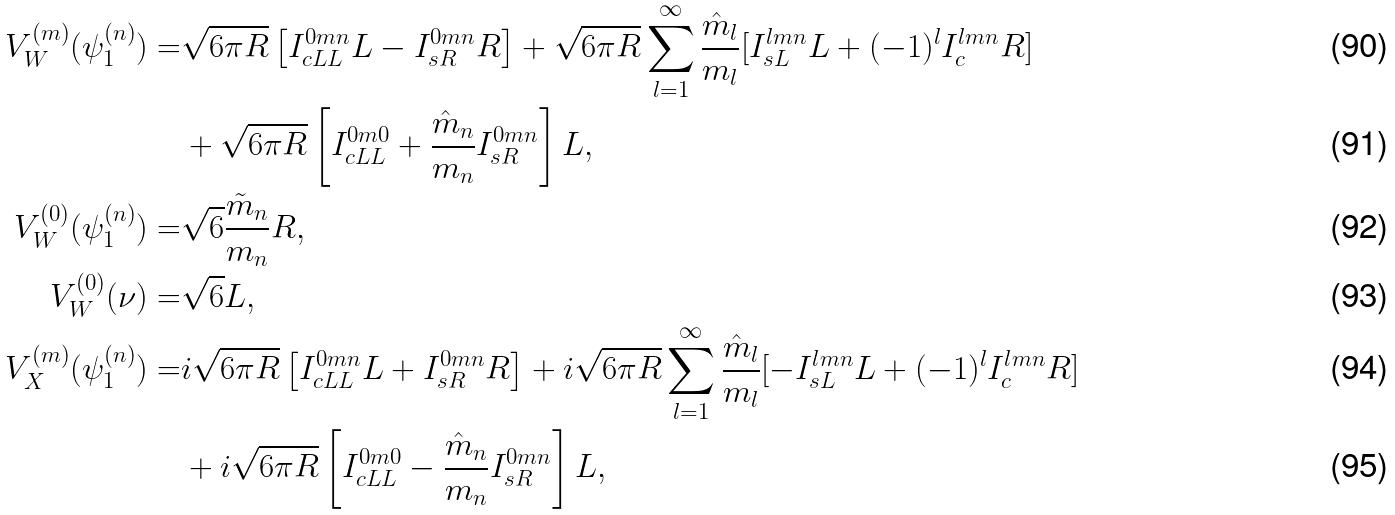<formula> <loc_0><loc_0><loc_500><loc_500>V _ { W } ^ { ( m ) } ( \psi _ { 1 } ^ { ( n ) } ) = & \sqrt { 6 \pi R } \left [ I _ { c L L } ^ { 0 m n } L - I _ { s R } ^ { 0 m n } R \right ] + \sqrt { 6 \pi R } \sum _ { l = 1 } ^ { \infty } \frac { \hat { m } _ { l } } { m _ { l } } [ I _ { s L } ^ { l m n } L + ( - 1 ) ^ { l } I _ { c } ^ { l m n } R ] \\ & + \sqrt { 6 \pi R } \left [ I _ { c L L } ^ { 0 m 0 } + \frac { \hat { m } _ { n } } { m _ { n } } I _ { s R } ^ { 0 m n } \right ] L , \\ V _ { W } ^ { ( 0 ) } ( \psi ^ { ( n ) } _ { 1 } ) = & \sqrt { 6 } \frac { \tilde { m } _ { n } } { m _ { n } } R , \\ V _ { W } ^ { ( 0 ) } ( \nu ) = & \sqrt { 6 } L , \\ V _ { X } ^ { ( m ) } ( \psi _ { 1 } ^ { ( n ) } ) = & i \sqrt { 6 \pi R } \left [ I _ { c L L } ^ { 0 m n } L + I _ { s R } ^ { 0 m n } R \right ] + i \sqrt { 6 \pi R } \sum _ { l = 1 } ^ { \infty } \frac { \hat { m } _ { l } } { m _ { l } } [ - I _ { s L } ^ { l m n } L + ( - 1 ) ^ { l } I _ { c } ^ { l m n } R ] \\ & + i \sqrt { 6 \pi R } \left [ I _ { c L L } ^ { 0 m 0 } - \frac { \hat { m } _ { n } } { m _ { n } } I _ { s R } ^ { 0 m n } \right ] L ,</formula> 